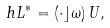Convert formula to latex. <formula><loc_0><loc_0><loc_500><loc_500>\ h L ^ { * } = ( \cdot \rfloor \omega ) \, U ,</formula> 